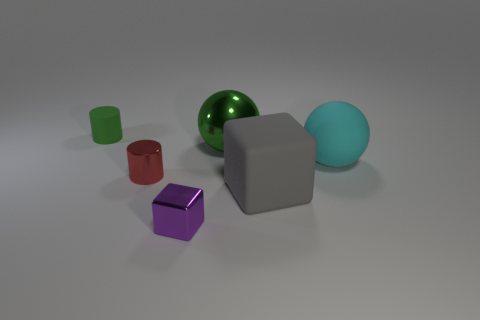Add 1 cyan shiny cubes. How many objects exist? 7 Subtract all balls. How many objects are left? 4 Subtract all tiny matte balls. Subtract all large gray matte objects. How many objects are left? 5 Add 2 tiny rubber things. How many tiny rubber things are left? 3 Add 6 purple metal objects. How many purple metal objects exist? 7 Subtract 0 yellow spheres. How many objects are left? 6 